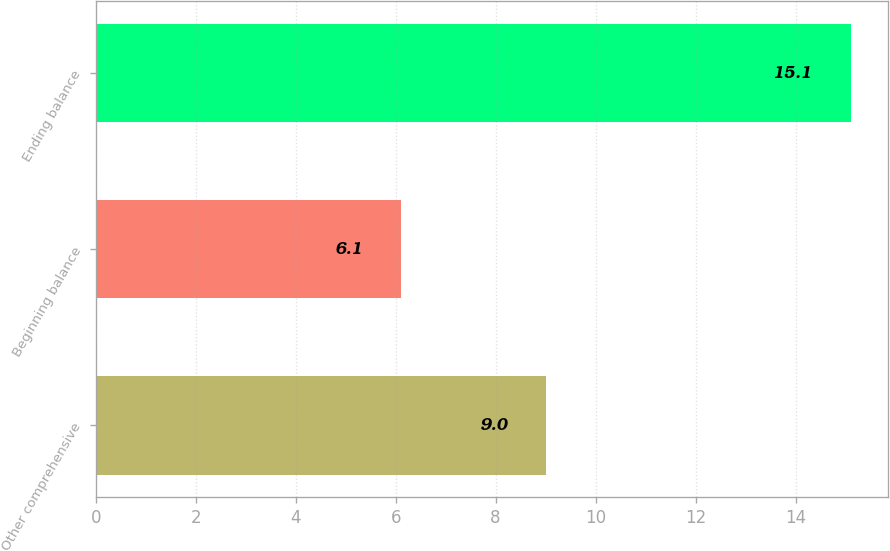<chart> <loc_0><loc_0><loc_500><loc_500><bar_chart><fcel>Other comprehensive<fcel>Beginning balance<fcel>Ending balance<nl><fcel>9<fcel>6.1<fcel>15.1<nl></chart> 